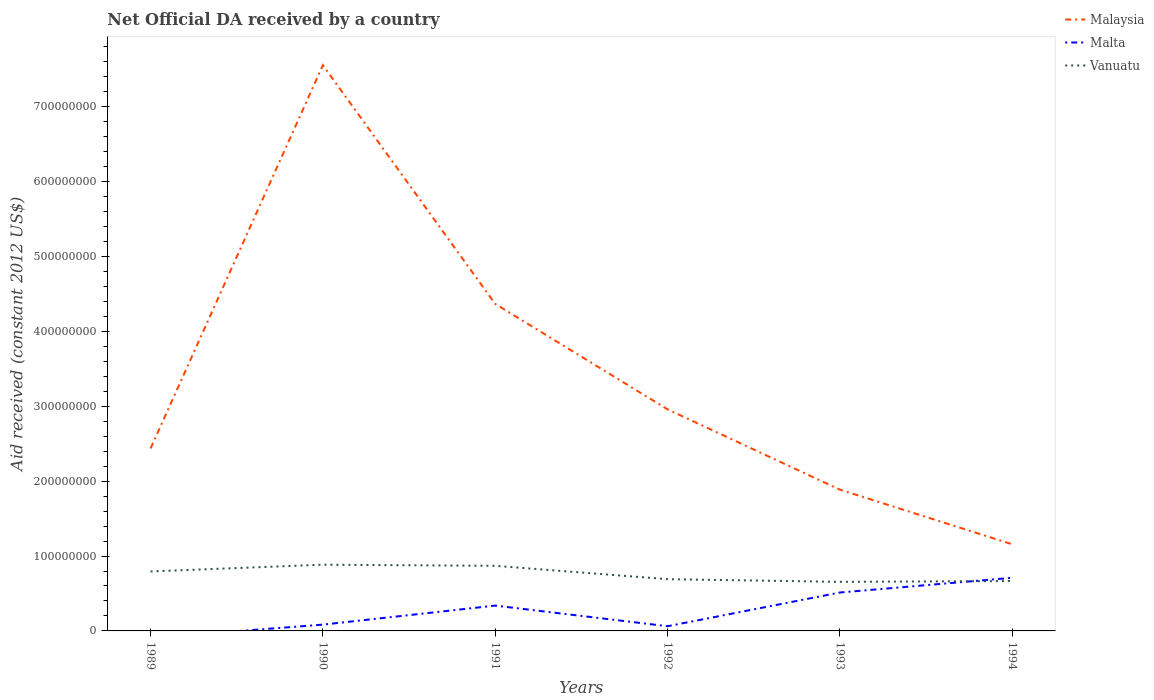Does the line corresponding to Malaysia intersect with the line corresponding to Malta?
Offer a very short reply. No. What is the total net official development assistance aid received in Vanuatu in the graph?
Make the answer very short. 1.03e+07. What is the difference between the highest and the second highest net official development assistance aid received in Malaysia?
Your response must be concise. 6.40e+08. What is the difference between the highest and the lowest net official development assistance aid received in Vanuatu?
Ensure brevity in your answer.  3. How many lines are there?
Your response must be concise. 3. What is the difference between two consecutive major ticks on the Y-axis?
Your answer should be very brief. 1.00e+08. Does the graph contain any zero values?
Provide a succinct answer. Yes. Where does the legend appear in the graph?
Your response must be concise. Top right. How are the legend labels stacked?
Ensure brevity in your answer.  Vertical. What is the title of the graph?
Provide a short and direct response. Net Official DA received by a country. Does "Oman" appear as one of the legend labels in the graph?
Your answer should be very brief. No. What is the label or title of the X-axis?
Your response must be concise. Years. What is the label or title of the Y-axis?
Make the answer very short. Aid received (constant 2012 US$). What is the Aid received (constant 2012 US$) of Malaysia in 1989?
Your response must be concise. 2.44e+08. What is the Aid received (constant 2012 US$) of Vanuatu in 1989?
Your answer should be very brief. 7.94e+07. What is the Aid received (constant 2012 US$) of Malaysia in 1990?
Make the answer very short. 7.56e+08. What is the Aid received (constant 2012 US$) in Malta in 1990?
Your response must be concise. 8.39e+06. What is the Aid received (constant 2012 US$) of Vanuatu in 1990?
Your response must be concise. 8.85e+07. What is the Aid received (constant 2012 US$) of Malaysia in 1991?
Keep it short and to the point. 4.37e+08. What is the Aid received (constant 2012 US$) of Malta in 1991?
Your answer should be very brief. 3.38e+07. What is the Aid received (constant 2012 US$) in Vanuatu in 1991?
Give a very brief answer. 8.69e+07. What is the Aid received (constant 2012 US$) of Malaysia in 1992?
Give a very brief answer. 2.96e+08. What is the Aid received (constant 2012 US$) of Malta in 1992?
Your answer should be compact. 6.27e+06. What is the Aid received (constant 2012 US$) of Vanuatu in 1992?
Offer a terse response. 6.91e+07. What is the Aid received (constant 2012 US$) of Malaysia in 1993?
Make the answer very short. 1.89e+08. What is the Aid received (constant 2012 US$) of Malta in 1993?
Provide a succinct answer. 5.13e+07. What is the Aid received (constant 2012 US$) of Vanuatu in 1993?
Give a very brief answer. 6.55e+07. What is the Aid received (constant 2012 US$) in Malaysia in 1994?
Give a very brief answer. 1.16e+08. What is the Aid received (constant 2012 US$) of Malta in 1994?
Provide a succinct answer. 7.10e+07. What is the Aid received (constant 2012 US$) of Vanuatu in 1994?
Offer a very short reply. 6.66e+07. Across all years, what is the maximum Aid received (constant 2012 US$) in Malaysia?
Provide a short and direct response. 7.56e+08. Across all years, what is the maximum Aid received (constant 2012 US$) in Malta?
Your response must be concise. 7.10e+07. Across all years, what is the maximum Aid received (constant 2012 US$) in Vanuatu?
Give a very brief answer. 8.85e+07. Across all years, what is the minimum Aid received (constant 2012 US$) of Malaysia?
Give a very brief answer. 1.16e+08. Across all years, what is the minimum Aid received (constant 2012 US$) of Malta?
Give a very brief answer. 0. Across all years, what is the minimum Aid received (constant 2012 US$) in Vanuatu?
Keep it short and to the point. 6.55e+07. What is the total Aid received (constant 2012 US$) of Malaysia in the graph?
Your answer should be compact. 2.04e+09. What is the total Aid received (constant 2012 US$) of Malta in the graph?
Give a very brief answer. 1.71e+08. What is the total Aid received (constant 2012 US$) in Vanuatu in the graph?
Provide a short and direct response. 4.56e+08. What is the difference between the Aid received (constant 2012 US$) in Malaysia in 1989 and that in 1990?
Keep it short and to the point. -5.12e+08. What is the difference between the Aid received (constant 2012 US$) in Vanuatu in 1989 and that in 1990?
Give a very brief answer. -9.02e+06. What is the difference between the Aid received (constant 2012 US$) of Malaysia in 1989 and that in 1991?
Make the answer very short. -1.93e+08. What is the difference between the Aid received (constant 2012 US$) of Vanuatu in 1989 and that in 1991?
Your answer should be very brief. -7.50e+06. What is the difference between the Aid received (constant 2012 US$) of Malaysia in 1989 and that in 1992?
Provide a short and direct response. -5.22e+07. What is the difference between the Aid received (constant 2012 US$) in Vanuatu in 1989 and that in 1992?
Your answer should be compact. 1.03e+07. What is the difference between the Aid received (constant 2012 US$) of Malaysia in 1989 and that in 1993?
Ensure brevity in your answer.  5.50e+07. What is the difference between the Aid received (constant 2012 US$) of Vanuatu in 1989 and that in 1993?
Offer a terse response. 1.39e+07. What is the difference between the Aid received (constant 2012 US$) in Malaysia in 1989 and that in 1994?
Ensure brevity in your answer.  1.28e+08. What is the difference between the Aid received (constant 2012 US$) in Vanuatu in 1989 and that in 1994?
Offer a terse response. 1.28e+07. What is the difference between the Aid received (constant 2012 US$) of Malaysia in 1990 and that in 1991?
Keep it short and to the point. 3.19e+08. What is the difference between the Aid received (constant 2012 US$) in Malta in 1990 and that in 1991?
Provide a short and direct response. -2.54e+07. What is the difference between the Aid received (constant 2012 US$) of Vanuatu in 1990 and that in 1991?
Offer a terse response. 1.52e+06. What is the difference between the Aid received (constant 2012 US$) in Malaysia in 1990 and that in 1992?
Your answer should be compact. 4.60e+08. What is the difference between the Aid received (constant 2012 US$) of Malta in 1990 and that in 1992?
Ensure brevity in your answer.  2.12e+06. What is the difference between the Aid received (constant 2012 US$) in Vanuatu in 1990 and that in 1992?
Provide a succinct answer. 1.94e+07. What is the difference between the Aid received (constant 2012 US$) in Malaysia in 1990 and that in 1993?
Keep it short and to the point. 5.67e+08. What is the difference between the Aid received (constant 2012 US$) in Malta in 1990 and that in 1993?
Provide a short and direct response. -4.29e+07. What is the difference between the Aid received (constant 2012 US$) in Vanuatu in 1990 and that in 1993?
Give a very brief answer. 2.29e+07. What is the difference between the Aid received (constant 2012 US$) in Malaysia in 1990 and that in 1994?
Your answer should be very brief. 6.40e+08. What is the difference between the Aid received (constant 2012 US$) of Malta in 1990 and that in 1994?
Provide a succinct answer. -6.26e+07. What is the difference between the Aid received (constant 2012 US$) in Vanuatu in 1990 and that in 1994?
Give a very brief answer. 2.18e+07. What is the difference between the Aid received (constant 2012 US$) in Malaysia in 1991 and that in 1992?
Offer a very short reply. 1.41e+08. What is the difference between the Aid received (constant 2012 US$) in Malta in 1991 and that in 1992?
Offer a terse response. 2.76e+07. What is the difference between the Aid received (constant 2012 US$) of Vanuatu in 1991 and that in 1992?
Provide a short and direct response. 1.78e+07. What is the difference between the Aid received (constant 2012 US$) in Malaysia in 1991 and that in 1993?
Ensure brevity in your answer.  2.48e+08. What is the difference between the Aid received (constant 2012 US$) of Malta in 1991 and that in 1993?
Give a very brief answer. -1.75e+07. What is the difference between the Aid received (constant 2012 US$) of Vanuatu in 1991 and that in 1993?
Offer a very short reply. 2.14e+07. What is the difference between the Aid received (constant 2012 US$) in Malaysia in 1991 and that in 1994?
Offer a terse response. 3.21e+08. What is the difference between the Aid received (constant 2012 US$) of Malta in 1991 and that in 1994?
Provide a succinct answer. -3.71e+07. What is the difference between the Aid received (constant 2012 US$) of Vanuatu in 1991 and that in 1994?
Make the answer very short. 2.03e+07. What is the difference between the Aid received (constant 2012 US$) of Malaysia in 1992 and that in 1993?
Your response must be concise. 1.07e+08. What is the difference between the Aid received (constant 2012 US$) of Malta in 1992 and that in 1993?
Your answer should be compact. -4.50e+07. What is the difference between the Aid received (constant 2012 US$) of Vanuatu in 1992 and that in 1993?
Ensure brevity in your answer.  3.57e+06. What is the difference between the Aid received (constant 2012 US$) of Malaysia in 1992 and that in 1994?
Ensure brevity in your answer.  1.80e+08. What is the difference between the Aid received (constant 2012 US$) of Malta in 1992 and that in 1994?
Offer a very short reply. -6.47e+07. What is the difference between the Aid received (constant 2012 US$) in Vanuatu in 1992 and that in 1994?
Your answer should be compact. 2.50e+06. What is the difference between the Aid received (constant 2012 US$) in Malaysia in 1993 and that in 1994?
Offer a very short reply. 7.30e+07. What is the difference between the Aid received (constant 2012 US$) of Malta in 1993 and that in 1994?
Offer a terse response. -1.97e+07. What is the difference between the Aid received (constant 2012 US$) in Vanuatu in 1993 and that in 1994?
Provide a succinct answer. -1.07e+06. What is the difference between the Aid received (constant 2012 US$) in Malaysia in 1989 and the Aid received (constant 2012 US$) in Malta in 1990?
Provide a succinct answer. 2.35e+08. What is the difference between the Aid received (constant 2012 US$) of Malaysia in 1989 and the Aid received (constant 2012 US$) of Vanuatu in 1990?
Offer a very short reply. 1.55e+08. What is the difference between the Aid received (constant 2012 US$) of Malaysia in 1989 and the Aid received (constant 2012 US$) of Malta in 1991?
Give a very brief answer. 2.10e+08. What is the difference between the Aid received (constant 2012 US$) of Malaysia in 1989 and the Aid received (constant 2012 US$) of Vanuatu in 1991?
Make the answer very short. 1.57e+08. What is the difference between the Aid received (constant 2012 US$) of Malaysia in 1989 and the Aid received (constant 2012 US$) of Malta in 1992?
Offer a terse response. 2.37e+08. What is the difference between the Aid received (constant 2012 US$) of Malaysia in 1989 and the Aid received (constant 2012 US$) of Vanuatu in 1992?
Your answer should be very brief. 1.75e+08. What is the difference between the Aid received (constant 2012 US$) of Malaysia in 1989 and the Aid received (constant 2012 US$) of Malta in 1993?
Offer a terse response. 1.92e+08. What is the difference between the Aid received (constant 2012 US$) of Malaysia in 1989 and the Aid received (constant 2012 US$) of Vanuatu in 1993?
Your answer should be compact. 1.78e+08. What is the difference between the Aid received (constant 2012 US$) in Malaysia in 1989 and the Aid received (constant 2012 US$) in Malta in 1994?
Make the answer very short. 1.73e+08. What is the difference between the Aid received (constant 2012 US$) of Malaysia in 1989 and the Aid received (constant 2012 US$) of Vanuatu in 1994?
Make the answer very short. 1.77e+08. What is the difference between the Aid received (constant 2012 US$) in Malaysia in 1990 and the Aid received (constant 2012 US$) in Malta in 1991?
Your answer should be very brief. 7.22e+08. What is the difference between the Aid received (constant 2012 US$) in Malaysia in 1990 and the Aid received (constant 2012 US$) in Vanuatu in 1991?
Provide a short and direct response. 6.69e+08. What is the difference between the Aid received (constant 2012 US$) of Malta in 1990 and the Aid received (constant 2012 US$) of Vanuatu in 1991?
Make the answer very short. -7.86e+07. What is the difference between the Aid received (constant 2012 US$) in Malaysia in 1990 and the Aid received (constant 2012 US$) in Malta in 1992?
Your response must be concise. 7.49e+08. What is the difference between the Aid received (constant 2012 US$) of Malaysia in 1990 and the Aid received (constant 2012 US$) of Vanuatu in 1992?
Your answer should be compact. 6.86e+08. What is the difference between the Aid received (constant 2012 US$) of Malta in 1990 and the Aid received (constant 2012 US$) of Vanuatu in 1992?
Offer a terse response. -6.07e+07. What is the difference between the Aid received (constant 2012 US$) in Malaysia in 1990 and the Aid received (constant 2012 US$) in Malta in 1993?
Offer a terse response. 7.04e+08. What is the difference between the Aid received (constant 2012 US$) of Malaysia in 1990 and the Aid received (constant 2012 US$) of Vanuatu in 1993?
Offer a terse response. 6.90e+08. What is the difference between the Aid received (constant 2012 US$) of Malta in 1990 and the Aid received (constant 2012 US$) of Vanuatu in 1993?
Offer a terse response. -5.72e+07. What is the difference between the Aid received (constant 2012 US$) in Malaysia in 1990 and the Aid received (constant 2012 US$) in Malta in 1994?
Offer a terse response. 6.85e+08. What is the difference between the Aid received (constant 2012 US$) in Malaysia in 1990 and the Aid received (constant 2012 US$) in Vanuatu in 1994?
Your answer should be very brief. 6.89e+08. What is the difference between the Aid received (constant 2012 US$) of Malta in 1990 and the Aid received (constant 2012 US$) of Vanuatu in 1994?
Provide a short and direct response. -5.82e+07. What is the difference between the Aid received (constant 2012 US$) of Malaysia in 1991 and the Aid received (constant 2012 US$) of Malta in 1992?
Give a very brief answer. 4.31e+08. What is the difference between the Aid received (constant 2012 US$) of Malaysia in 1991 and the Aid received (constant 2012 US$) of Vanuatu in 1992?
Make the answer very short. 3.68e+08. What is the difference between the Aid received (constant 2012 US$) of Malta in 1991 and the Aid received (constant 2012 US$) of Vanuatu in 1992?
Give a very brief answer. -3.53e+07. What is the difference between the Aid received (constant 2012 US$) of Malaysia in 1991 and the Aid received (constant 2012 US$) of Malta in 1993?
Keep it short and to the point. 3.86e+08. What is the difference between the Aid received (constant 2012 US$) of Malaysia in 1991 and the Aid received (constant 2012 US$) of Vanuatu in 1993?
Provide a short and direct response. 3.71e+08. What is the difference between the Aid received (constant 2012 US$) of Malta in 1991 and the Aid received (constant 2012 US$) of Vanuatu in 1993?
Provide a short and direct response. -3.17e+07. What is the difference between the Aid received (constant 2012 US$) of Malaysia in 1991 and the Aid received (constant 2012 US$) of Malta in 1994?
Offer a very short reply. 3.66e+08. What is the difference between the Aid received (constant 2012 US$) in Malaysia in 1991 and the Aid received (constant 2012 US$) in Vanuatu in 1994?
Provide a short and direct response. 3.70e+08. What is the difference between the Aid received (constant 2012 US$) of Malta in 1991 and the Aid received (constant 2012 US$) of Vanuatu in 1994?
Give a very brief answer. -3.28e+07. What is the difference between the Aid received (constant 2012 US$) of Malaysia in 1992 and the Aid received (constant 2012 US$) of Malta in 1993?
Make the answer very short. 2.45e+08. What is the difference between the Aid received (constant 2012 US$) in Malaysia in 1992 and the Aid received (constant 2012 US$) in Vanuatu in 1993?
Your response must be concise. 2.30e+08. What is the difference between the Aid received (constant 2012 US$) in Malta in 1992 and the Aid received (constant 2012 US$) in Vanuatu in 1993?
Offer a very short reply. -5.93e+07. What is the difference between the Aid received (constant 2012 US$) of Malaysia in 1992 and the Aid received (constant 2012 US$) of Malta in 1994?
Keep it short and to the point. 2.25e+08. What is the difference between the Aid received (constant 2012 US$) of Malaysia in 1992 and the Aid received (constant 2012 US$) of Vanuatu in 1994?
Keep it short and to the point. 2.29e+08. What is the difference between the Aid received (constant 2012 US$) in Malta in 1992 and the Aid received (constant 2012 US$) in Vanuatu in 1994?
Ensure brevity in your answer.  -6.03e+07. What is the difference between the Aid received (constant 2012 US$) in Malaysia in 1993 and the Aid received (constant 2012 US$) in Malta in 1994?
Your answer should be compact. 1.18e+08. What is the difference between the Aid received (constant 2012 US$) of Malaysia in 1993 and the Aid received (constant 2012 US$) of Vanuatu in 1994?
Offer a terse response. 1.22e+08. What is the difference between the Aid received (constant 2012 US$) in Malta in 1993 and the Aid received (constant 2012 US$) in Vanuatu in 1994?
Provide a short and direct response. -1.53e+07. What is the average Aid received (constant 2012 US$) in Malaysia per year?
Provide a short and direct response. 3.39e+08. What is the average Aid received (constant 2012 US$) in Malta per year?
Offer a terse response. 2.85e+07. What is the average Aid received (constant 2012 US$) in Vanuatu per year?
Offer a very short reply. 7.60e+07. In the year 1989, what is the difference between the Aid received (constant 2012 US$) in Malaysia and Aid received (constant 2012 US$) in Vanuatu?
Offer a very short reply. 1.64e+08. In the year 1990, what is the difference between the Aid received (constant 2012 US$) of Malaysia and Aid received (constant 2012 US$) of Malta?
Keep it short and to the point. 7.47e+08. In the year 1990, what is the difference between the Aid received (constant 2012 US$) in Malaysia and Aid received (constant 2012 US$) in Vanuatu?
Give a very brief answer. 6.67e+08. In the year 1990, what is the difference between the Aid received (constant 2012 US$) of Malta and Aid received (constant 2012 US$) of Vanuatu?
Provide a short and direct response. -8.01e+07. In the year 1991, what is the difference between the Aid received (constant 2012 US$) in Malaysia and Aid received (constant 2012 US$) in Malta?
Keep it short and to the point. 4.03e+08. In the year 1991, what is the difference between the Aid received (constant 2012 US$) of Malaysia and Aid received (constant 2012 US$) of Vanuatu?
Keep it short and to the point. 3.50e+08. In the year 1991, what is the difference between the Aid received (constant 2012 US$) in Malta and Aid received (constant 2012 US$) in Vanuatu?
Make the answer very short. -5.31e+07. In the year 1992, what is the difference between the Aid received (constant 2012 US$) in Malaysia and Aid received (constant 2012 US$) in Malta?
Your answer should be very brief. 2.90e+08. In the year 1992, what is the difference between the Aid received (constant 2012 US$) of Malaysia and Aid received (constant 2012 US$) of Vanuatu?
Give a very brief answer. 2.27e+08. In the year 1992, what is the difference between the Aid received (constant 2012 US$) of Malta and Aid received (constant 2012 US$) of Vanuatu?
Offer a very short reply. -6.28e+07. In the year 1993, what is the difference between the Aid received (constant 2012 US$) in Malaysia and Aid received (constant 2012 US$) in Malta?
Offer a terse response. 1.37e+08. In the year 1993, what is the difference between the Aid received (constant 2012 US$) in Malaysia and Aid received (constant 2012 US$) in Vanuatu?
Keep it short and to the point. 1.23e+08. In the year 1993, what is the difference between the Aid received (constant 2012 US$) in Malta and Aid received (constant 2012 US$) in Vanuatu?
Your response must be concise. -1.43e+07. In the year 1994, what is the difference between the Aid received (constant 2012 US$) of Malaysia and Aid received (constant 2012 US$) of Malta?
Make the answer very short. 4.48e+07. In the year 1994, what is the difference between the Aid received (constant 2012 US$) of Malaysia and Aid received (constant 2012 US$) of Vanuatu?
Your answer should be very brief. 4.91e+07. In the year 1994, what is the difference between the Aid received (constant 2012 US$) in Malta and Aid received (constant 2012 US$) in Vanuatu?
Provide a succinct answer. 4.34e+06. What is the ratio of the Aid received (constant 2012 US$) of Malaysia in 1989 to that in 1990?
Make the answer very short. 0.32. What is the ratio of the Aid received (constant 2012 US$) in Vanuatu in 1989 to that in 1990?
Provide a succinct answer. 0.9. What is the ratio of the Aid received (constant 2012 US$) in Malaysia in 1989 to that in 1991?
Keep it short and to the point. 0.56. What is the ratio of the Aid received (constant 2012 US$) in Vanuatu in 1989 to that in 1991?
Give a very brief answer. 0.91. What is the ratio of the Aid received (constant 2012 US$) in Malaysia in 1989 to that in 1992?
Your response must be concise. 0.82. What is the ratio of the Aid received (constant 2012 US$) in Vanuatu in 1989 to that in 1992?
Provide a short and direct response. 1.15. What is the ratio of the Aid received (constant 2012 US$) in Malaysia in 1989 to that in 1993?
Offer a very short reply. 1.29. What is the ratio of the Aid received (constant 2012 US$) of Vanuatu in 1989 to that in 1993?
Provide a short and direct response. 1.21. What is the ratio of the Aid received (constant 2012 US$) of Malaysia in 1989 to that in 1994?
Your answer should be compact. 2.11. What is the ratio of the Aid received (constant 2012 US$) in Vanuatu in 1989 to that in 1994?
Ensure brevity in your answer.  1.19. What is the ratio of the Aid received (constant 2012 US$) in Malaysia in 1990 to that in 1991?
Offer a very short reply. 1.73. What is the ratio of the Aid received (constant 2012 US$) in Malta in 1990 to that in 1991?
Keep it short and to the point. 0.25. What is the ratio of the Aid received (constant 2012 US$) in Vanuatu in 1990 to that in 1991?
Your response must be concise. 1.02. What is the ratio of the Aid received (constant 2012 US$) in Malaysia in 1990 to that in 1992?
Give a very brief answer. 2.55. What is the ratio of the Aid received (constant 2012 US$) in Malta in 1990 to that in 1992?
Keep it short and to the point. 1.34. What is the ratio of the Aid received (constant 2012 US$) of Vanuatu in 1990 to that in 1992?
Give a very brief answer. 1.28. What is the ratio of the Aid received (constant 2012 US$) in Malaysia in 1990 to that in 1993?
Your answer should be very brief. 4. What is the ratio of the Aid received (constant 2012 US$) of Malta in 1990 to that in 1993?
Your answer should be compact. 0.16. What is the ratio of the Aid received (constant 2012 US$) in Vanuatu in 1990 to that in 1993?
Provide a short and direct response. 1.35. What is the ratio of the Aid received (constant 2012 US$) in Malaysia in 1990 to that in 1994?
Your answer should be compact. 6.53. What is the ratio of the Aid received (constant 2012 US$) of Malta in 1990 to that in 1994?
Offer a very short reply. 0.12. What is the ratio of the Aid received (constant 2012 US$) of Vanuatu in 1990 to that in 1994?
Your answer should be compact. 1.33. What is the ratio of the Aid received (constant 2012 US$) in Malaysia in 1991 to that in 1992?
Your answer should be very brief. 1.48. What is the ratio of the Aid received (constant 2012 US$) of Malta in 1991 to that in 1992?
Your answer should be compact. 5.39. What is the ratio of the Aid received (constant 2012 US$) in Vanuatu in 1991 to that in 1992?
Your response must be concise. 1.26. What is the ratio of the Aid received (constant 2012 US$) in Malaysia in 1991 to that in 1993?
Make the answer very short. 2.31. What is the ratio of the Aid received (constant 2012 US$) of Malta in 1991 to that in 1993?
Your answer should be compact. 0.66. What is the ratio of the Aid received (constant 2012 US$) in Vanuatu in 1991 to that in 1993?
Offer a terse response. 1.33. What is the ratio of the Aid received (constant 2012 US$) in Malaysia in 1991 to that in 1994?
Offer a very short reply. 3.77. What is the ratio of the Aid received (constant 2012 US$) in Malta in 1991 to that in 1994?
Provide a short and direct response. 0.48. What is the ratio of the Aid received (constant 2012 US$) in Vanuatu in 1991 to that in 1994?
Ensure brevity in your answer.  1.31. What is the ratio of the Aid received (constant 2012 US$) of Malaysia in 1992 to that in 1993?
Your response must be concise. 1.57. What is the ratio of the Aid received (constant 2012 US$) in Malta in 1992 to that in 1993?
Offer a very short reply. 0.12. What is the ratio of the Aid received (constant 2012 US$) in Vanuatu in 1992 to that in 1993?
Keep it short and to the point. 1.05. What is the ratio of the Aid received (constant 2012 US$) in Malaysia in 1992 to that in 1994?
Provide a short and direct response. 2.56. What is the ratio of the Aid received (constant 2012 US$) in Malta in 1992 to that in 1994?
Your answer should be compact. 0.09. What is the ratio of the Aid received (constant 2012 US$) of Vanuatu in 1992 to that in 1994?
Provide a short and direct response. 1.04. What is the ratio of the Aid received (constant 2012 US$) in Malaysia in 1993 to that in 1994?
Offer a very short reply. 1.63. What is the ratio of the Aid received (constant 2012 US$) of Malta in 1993 to that in 1994?
Provide a short and direct response. 0.72. What is the ratio of the Aid received (constant 2012 US$) in Vanuatu in 1993 to that in 1994?
Give a very brief answer. 0.98. What is the difference between the highest and the second highest Aid received (constant 2012 US$) of Malaysia?
Provide a succinct answer. 3.19e+08. What is the difference between the highest and the second highest Aid received (constant 2012 US$) in Malta?
Your response must be concise. 1.97e+07. What is the difference between the highest and the second highest Aid received (constant 2012 US$) in Vanuatu?
Your answer should be very brief. 1.52e+06. What is the difference between the highest and the lowest Aid received (constant 2012 US$) in Malaysia?
Your response must be concise. 6.40e+08. What is the difference between the highest and the lowest Aid received (constant 2012 US$) in Malta?
Provide a succinct answer. 7.10e+07. What is the difference between the highest and the lowest Aid received (constant 2012 US$) in Vanuatu?
Keep it short and to the point. 2.29e+07. 